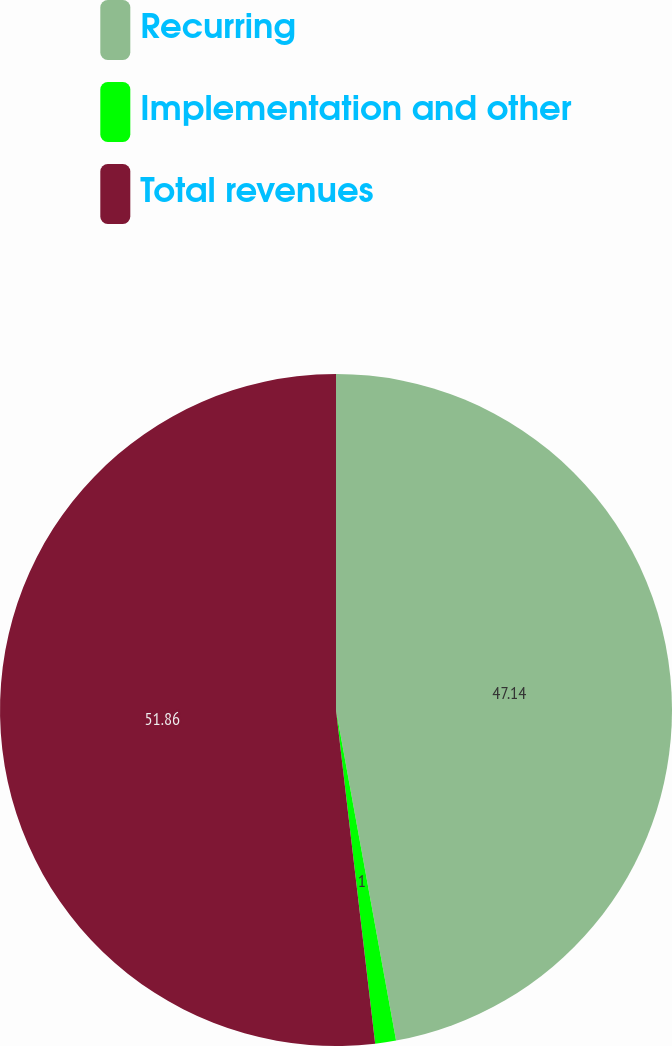Convert chart to OTSL. <chart><loc_0><loc_0><loc_500><loc_500><pie_chart><fcel>Recurring<fcel>Implementation and other<fcel>Total revenues<nl><fcel>47.14%<fcel>1.0%<fcel>51.86%<nl></chart> 